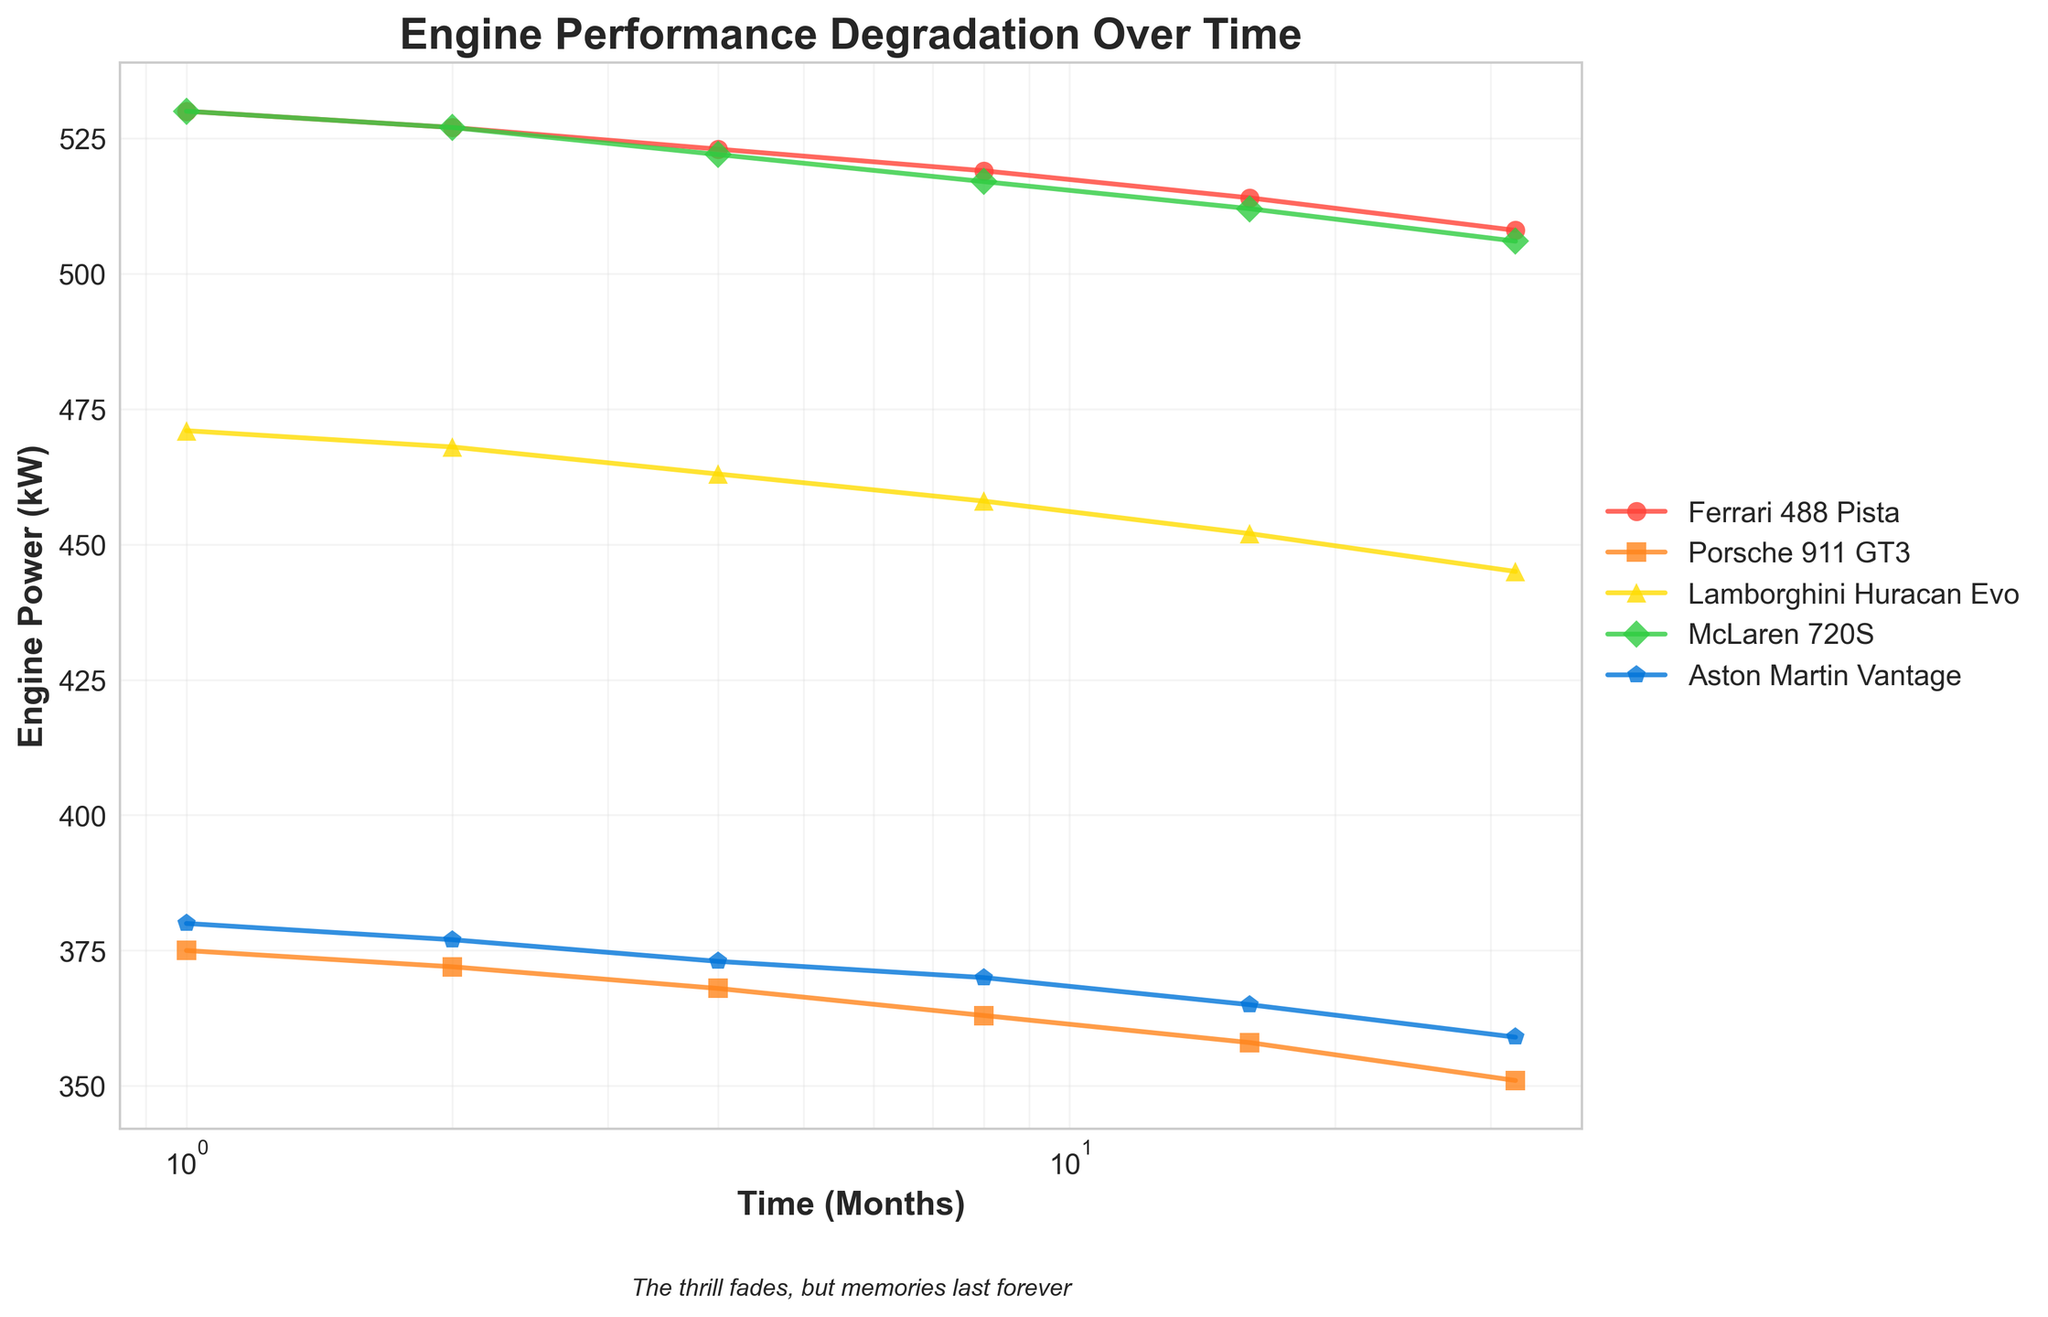Which car model begins with the highest engine power and what is that power? The car models are represented with different colors and markers. By examining the left-most points of the lines, the model with the highest initial power corresponds to Ferrari 488 Pista and McLaren 720S, both starting at 530 kW.
Answer: Ferrari 488 Pista, McLaren 720S; 530 kW Which car model shows the most significant decline in engine power over 32 months? By comparing the decline from the first to the last data point for each car model, Ferrari 488 Pista and McLaren 720S show significant declines from 530 kW to 508 kW and 506 kW respectively. The difference for Ferrari 488 Pista is 530 - 508 = 22 kW and for McLaren 720S it is 530 - 506 = 24 kW. Among these, the McLaren 720S has a slightly larger decline.
Answer: McLaren 720S Does any car model maintain its engine power above 500 kW throughout the 32 months? Look at the lines for each model and check if any of them stay above the 500 kW mark. The Ferrari 488 Pista, McLaren 720S, and Lamborghini Huracan Evo all start above 500 kW, but only the Ferrari 488 Pista and McLaren 720S remain above 500 kW for all data points.
Answer: Yes, Ferrari 488 Pista and McLaren 720S What is the general trend for engine power with time observed in the plot? All the lines representing different car models generally decline over time, indicating that engine power degrades as time progresses. This can be seen by the downward slopes in each line.
Answer: Engine power decreases over time Which car models have the smallest performance degradation after 32 months? To determine this, measure the drop from the initial to the final engine power for each model. Calculate the power depreciation: 
- Ferrari 488 Pista: 530 - 508 = 22 kW
- McLaren 720S: 530 - 506 = 24 kW
- Lamborghini Huracan Evo: 471 - 445 = 26 kW
- Porsche 911 GT3: 375 - 351 = 24 kW
- Aston Martin Vantage: 380 - 359 = 21 kW
Among these, Aston Martin Vantage has the smallest degradation.
Answer: Aston Martin Vantage 